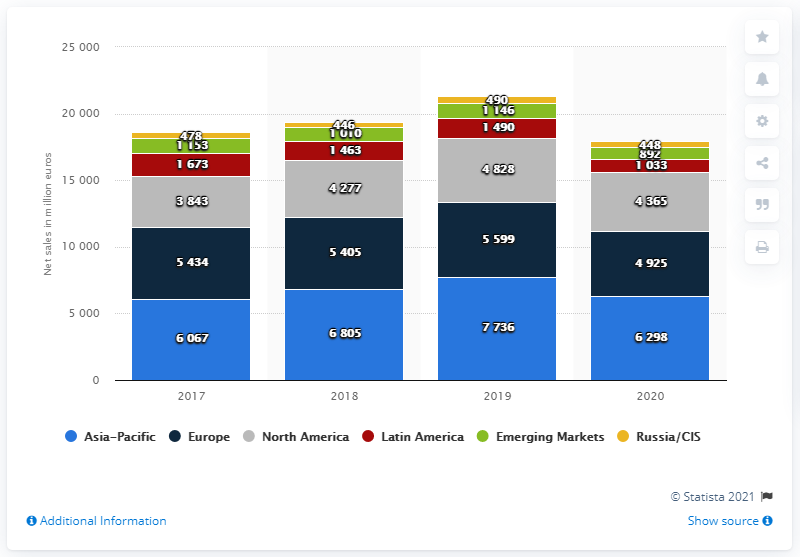Point out several critical features in this image. In 2020, the net sales of the adidas brand in the Asia-Pacific region totaled 6,298. 